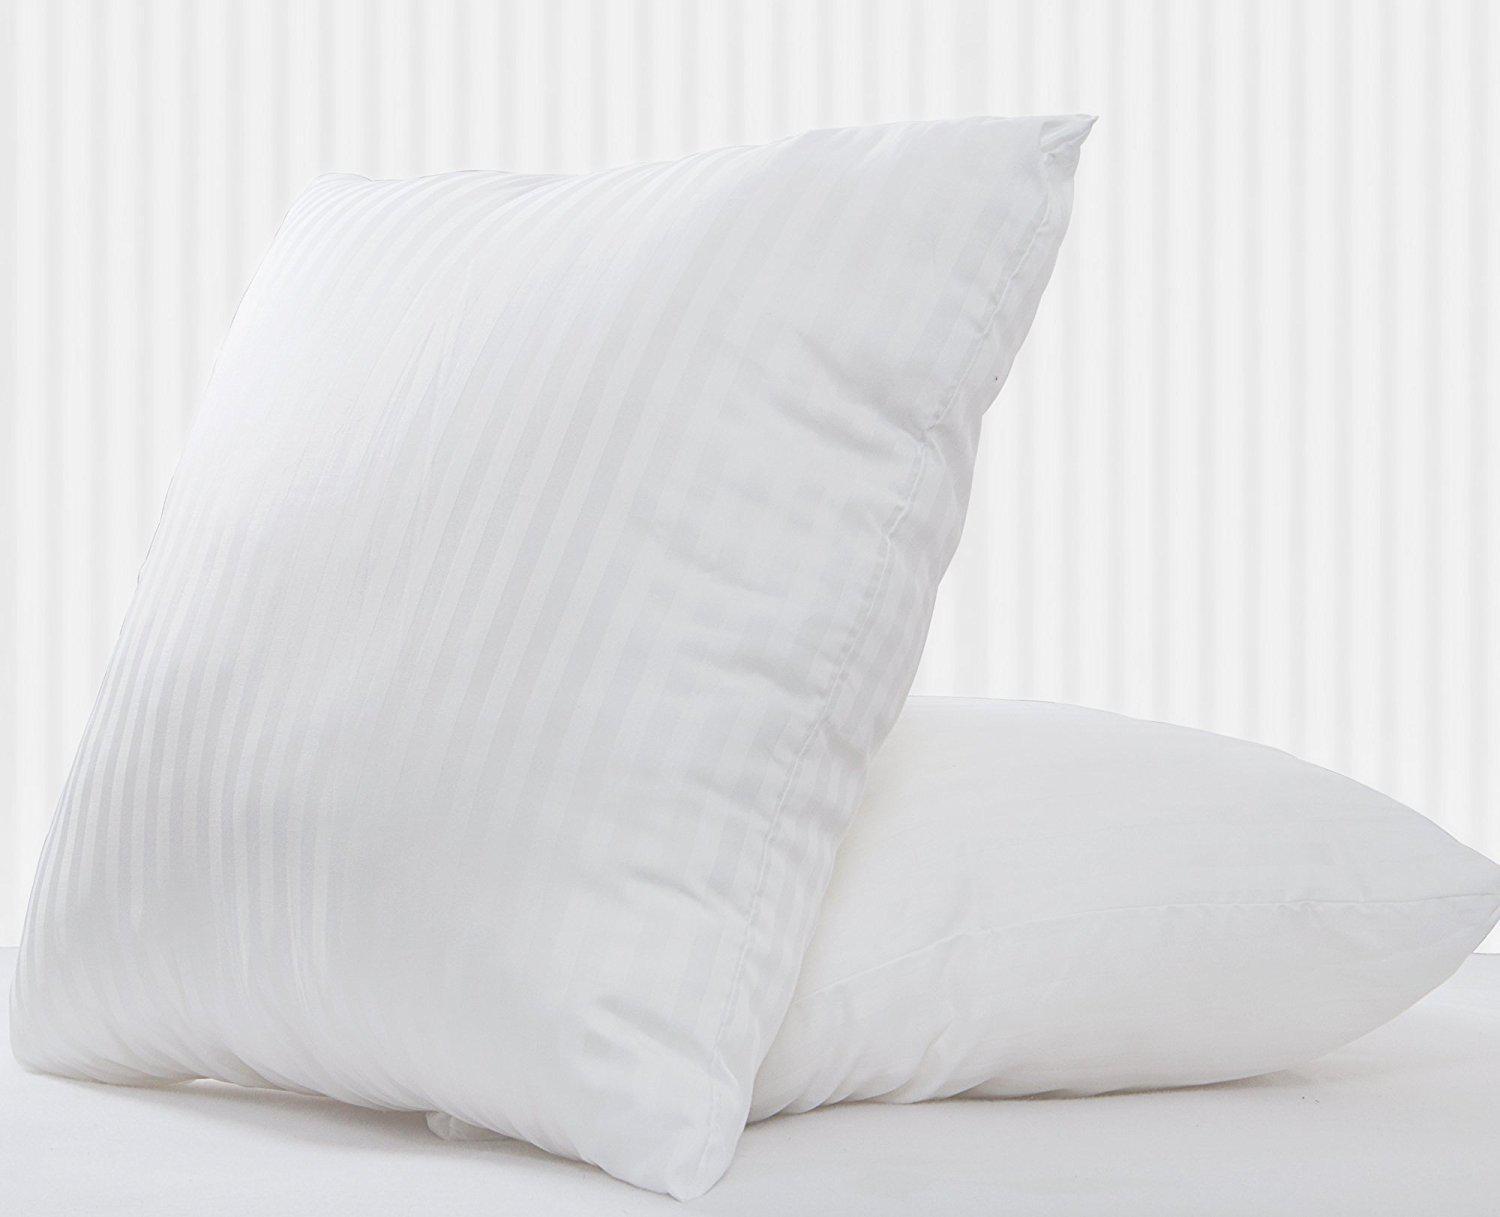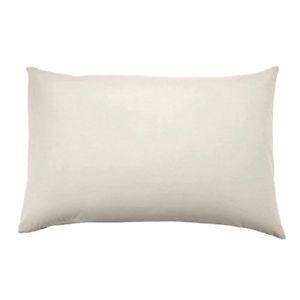The first image is the image on the left, the second image is the image on the right. Assess this claim about the two images: "Two pillows are visible in the left image, while there is just one pillow on the right". Correct or not? Answer yes or no. Yes. The first image is the image on the left, the second image is the image on the right. Analyze the images presented: Is the assertion "One image shows a single white rectangular pillow, and the other image shows a square upright pillow overlapping a pillow on its side." valid? Answer yes or no. Yes. 